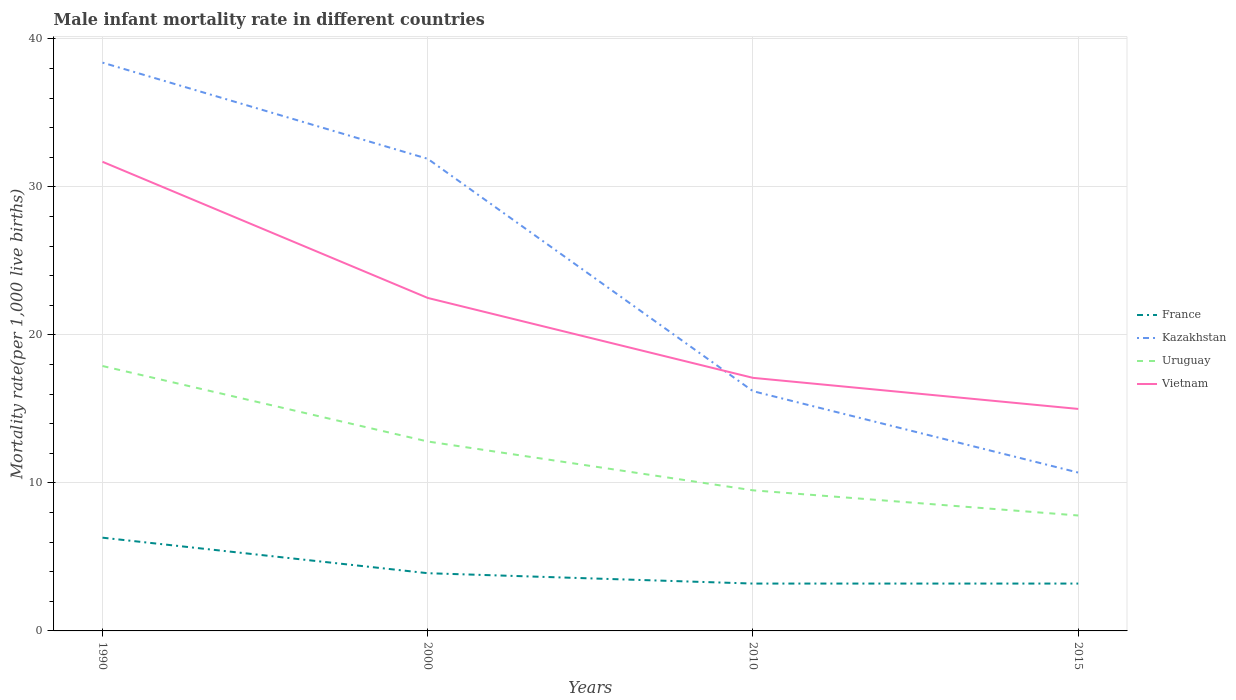How many different coloured lines are there?
Ensure brevity in your answer.  4. Does the line corresponding to Kazakhstan intersect with the line corresponding to France?
Your answer should be compact. No. Across all years, what is the maximum male infant mortality rate in France?
Offer a terse response. 3.2. In which year was the male infant mortality rate in Vietnam maximum?
Provide a short and direct response. 2015. What is the total male infant mortality rate in Kazakhstan in the graph?
Ensure brevity in your answer.  6.5. What is the difference between the highest and the second highest male infant mortality rate in Uruguay?
Give a very brief answer. 10.1. How many years are there in the graph?
Your answer should be compact. 4. Does the graph contain grids?
Your answer should be very brief. Yes. How many legend labels are there?
Your answer should be very brief. 4. What is the title of the graph?
Your answer should be compact. Male infant mortality rate in different countries. Does "Zimbabwe" appear as one of the legend labels in the graph?
Keep it short and to the point. No. What is the label or title of the Y-axis?
Provide a short and direct response. Mortality rate(per 1,0 live births). What is the Mortality rate(per 1,000 live births) of France in 1990?
Offer a very short reply. 6.3. What is the Mortality rate(per 1,000 live births) of Kazakhstan in 1990?
Keep it short and to the point. 38.4. What is the Mortality rate(per 1,000 live births) in Vietnam in 1990?
Offer a terse response. 31.7. What is the Mortality rate(per 1,000 live births) in France in 2000?
Your answer should be very brief. 3.9. What is the Mortality rate(per 1,000 live births) in Kazakhstan in 2000?
Your answer should be very brief. 31.9. What is the Mortality rate(per 1,000 live births) in Uruguay in 2000?
Give a very brief answer. 12.8. What is the Mortality rate(per 1,000 live births) in Vietnam in 2000?
Your answer should be very brief. 22.5. What is the Mortality rate(per 1,000 live births) in Uruguay in 2010?
Provide a succinct answer. 9.5. What is the Mortality rate(per 1,000 live births) in Vietnam in 2010?
Offer a very short reply. 17.1. What is the Mortality rate(per 1,000 live births) of France in 2015?
Make the answer very short. 3.2. What is the Mortality rate(per 1,000 live births) in Kazakhstan in 2015?
Offer a very short reply. 10.7. Across all years, what is the maximum Mortality rate(per 1,000 live births) of France?
Provide a short and direct response. 6.3. Across all years, what is the maximum Mortality rate(per 1,000 live births) of Kazakhstan?
Your answer should be compact. 38.4. Across all years, what is the maximum Mortality rate(per 1,000 live births) of Vietnam?
Your answer should be compact. 31.7. Across all years, what is the minimum Mortality rate(per 1,000 live births) in Vietnam?
Keep it short and to the point. 15. What is the total Mortality rate(per 1,000 live births) in Kazakhstan in the graph?
Offer a terse response. 97.2. What is the total Mortality rate(per 1,000 live births) of Vietnam in the graph?
Keep it short and to the point. 86.3. What is the difference between the Mortality rate(per 1,000 live births) of Uruguay in 1990 and that in 2000?
Keep it short and to the point. 5.1. What is the difference between the Mortality rate(per 1,000 live births) of Vietnam in 1990 and that in 2000?
Provide a short and direct response. 9.2. What is the difference between the Mortality rate(per 1,000 live births) of Kazakhstan in 1990 and that in 2010?
Your response must be concise. 22.2. What is the difference between the Mortality rate(per 1,000 live births) in Uruguay in 1990 and that in 2010?
Ensure brevity in your answer.  8.4. What is the difference between the Mortality rate(per 1,000 live births) in Vietnam in 1990 and that in 2010?
Your answer should be very brief. 14.6. What is the difference between the Mortality rate(per 1,000 live births) of France in 1990 and that in 2015?
Give a very brief answer. 3.1. What is the difference between the Mortality rate(per 1,000 live births) of Kazakhstan in 1990 and that in 2015?
Ensure brevity in your answer.  27.7. What is the difference between the Mortality rate(per 1,000 live births) of Uruguay in 1990 and that in 2015?
Your answer should be very brief. 10.1. What is the difference between the Mortality rate(per 1,000 live births) of France in 2000 and that in 2010?
Offer a terse response. 0.7. What is the difference between the Mortality rate(per 1,000 live births) in Kazakhstan in 2000 and that in 2010?
Give a very brief answer. 15.7. What is the difference between the Mortality rate(per 1,000 live births) in Uruguay in 2000 and that in 2010?
Keep it short and to the point. 3.3. What is the difference between the Mortality rate(per 1,000 live births) in Kazakhstan in 2000 and that in 2015?
Your response must be concise. 21.2. What is the difference between the Mortality rate(per 1,000 live births) in Uruguay in 2000 and that in 2015?
Provide a succinct answer. 5. What is the difference between the Mortality rate(per 1,000 live births) in Vietnam in 2000 and that in 2015?
Provide a succinct answer. 7.5. What is the difference between the Mortality rate(per 1,000 live births) of France in 2010 and that in 2015?
Keep it short and to the point. 0. What is the difference between the Mortality rate(per 1,000 live births) of Kazakhstan in 2010 and that in 2015?
Provide a succinct answer. 5.5. What is the difference between the Mortality rate(per 1,000 live births) of Vietnam in 2010 and that in 2015?
Your answer should be compact. 2.1. What is the difference between the Mortality rate(per 1,000 live births) of France in 1990 and the Mortality rate(per 1,000 live births) of Kazakhstan in 2000?
Your answer should be compact. -25.6. What is the difference between the Mortality rate(per 1,000 live births) of France in 1990 and the Mortality rate(per 1,000 live births) of Vietnam in 2000?
Offer a very short reply. -16.2. What is the difference between the Mortality rate(per 1,000 live births) in Kazakhstan in 1990 and the Mortality rate(per 1,000 live births) in Uruguay in 2000?
Make the answer very short. 25.6. What is the difference between the Mortality rate(per 1,000 live births) of France in 1990 and the Mortality rate(per 1,000 live births) of Kazakhstan in 2010?
Make the answer very short. -9.9. What is the difference between the Mortality rate(per 1,000 live births) in France in 1990 and the Mortality rate(per 1,000 live births) in Uruguay in 2010?
Make the answer very short. -3.2. What is the difference between the Mortality rate(per 1,000 live births) of Kazakhstan in 1990 and the Mortality rate(per 1,000 live births) of Uruguay in 2010?
Your answer should be compact. 28.9. What is the difference between the Mortality rate(per 1,000 live births) in Kazakhstan in 1990 and the Mortality rate(per 1,000 live births) in Vietnam in 2010?
Your answer should be very brief. 21.3. What is the difference between the Mortality rate(per 1,000 live births) in Uruguay in 1990 and the Mortality rate(per 1,000 live births) in Vietnam in 2010?
Give a very brief answer. 0.8. What is the difference between the Mortality rate(per 1,000 live births) of France in 1990 and the Mortality rate(per 1,000 live births) of Uruguay in 2015?
Offer a terse response. -1.5. What is the difference between the Mortality rate(per 1,000 live births) of Kazakhstan in 1990 and the Mortality rate(per 1,000 live births) of Uruguay in 2015?
Your answer should be very brief. 30.6. What is the difference between the Mortality rate(per 1,000 live births) in Kazakhstan in 1990 and the Mortality rate(per 1,000 live births) in Vietnam in 2015?
Offer a very short reply. 23.4. What is the difference between the Mortality rate(per 1,000 live births) in France in 2000 and the Mortality rate(per 1,000 live births) in Kazakhstan in 2010?
Give a very brief answer. -12.3. What is the difference between the Mortality rate(per 1,000 live births) of France in 2000 and the Mortality rate(per 1,000 live births) of Uruguay in 2010?
Your response must be concise. -5.6. What is the difference between the Mortality rate(per 1,000 live births) of Kazakhstan in 2000 and the Mortality rate(per 1,000 live births) of Uruguay in 2010?
Provide a short and direct response. 22.4. What is the difference between the Mortality rate(per 1,000 live births) in Kazakhstan in 2000 and the Mortality rate(per 1,000 live births) in Vietnam in 2010?
Offer a very short reply. 14.8. What is the difference between the Mortality rate(per 1,000 live births) in Uruguay in 2000 and the Mortality rate(per 1,000 live births) in Vietnam in 2010?
Your answer should be very brief. -4.3. What is the difference between the Mortality rate(per 1,000 live births) in France in 2000 and the Mortality rate(per 1,000 live births) in Uruguay in 2015?
Provide a short and direct response. -3.9. What is the difference between the Mortality rate(per 1,000 live births) of Kazakhstan in 2000 and the Mortality rate(per 1,000 live births) of Uruguay in 2015?
Give a very brief answer. 24.1. What is the difference between the Mortality rate(per 1,000 live births) of Kazakhstan in 2000 and the Mortality rate(per 1,000 live births) of Vietnam in 2015?
Offer a very short reply. 16.9. What is the average Mortality rate(per 1,000 live births) in France per year?
Your answer should be compact. 4.15. What is the average Mortality rate(per 1,000 live births) of Kazakhstan per year?
Your answer should be compact. 24.3. What is the average Mortality rate(per 1,000 live births) in Vietnam per year?
Make the answer very short. 21.57. In the year 1990, what is the difference between the Mortality rate(per 1,000 live births) of France and Mortality rate(per 1,000 live births) of Kazakhstan?
Provide a short and direct response. -32.1. In the year 1990, what is the difference between the Mortality rate(per 1,000 live births) of France and Mortality rate(per 1,000 live births) of Uruguay?
Your response must be concise. -11.6. In the year 1990, what is the difference between the Mortality rate(per 1,000 live births) of France and Mortality rate(per 1,000 live births) of Vietnam?
Your answer should be very brief. -25.4. In the year 1990, what is the difference between the Mortality rate(per 1,000 live births) in Kazakhstan and Mortality rate(per 1,000 live births) in Uruguay?
Give a very brief answer. 20.5. In the year 1990, what is the difference between the Mortality rate(per 1,000 live births) in Kazakhstan and Mortality rate(per 1,000 live births) in Vietnam?
Your answer should be very brief. 6.7. In the year 2000, what is the difference between the Mortality rate(per 1,000 live births) in France and Mortality rate(per 1,000 live births) in Kazakhstan?
Provide a short and direct response. -28. In the year 2000, what is the difference between the Mortality rate(per 1,000 live births) of France and Mortality rate(per 1,000 live births) of Vietnam?
Offer a very short reply. -18.6. In the year 2000, what is the difference between the Mortality rate(per 1,000 live births) of Kazakhstan and Mortality rate(per 1,000 live births) of Uruguay?
Provide a succinct answer. 19.1. In the year 2000, what is the difference between the Mortality rate(per 1,000 live births) in Kazakhstan and Mortality rate(per 1,000 live births) in Vietnam?
Provide a succinct answer. 9.4. In the year 2000, what is the difference between the Mortality rate(per 1,000 live births) of Uruguay and Mortality rate(per 1,000 live births) of Vietnam?
Provide a short and direct response. -9.7. In the year 2010, what is the difference between the Mortality rate(per 1,000 live births) of France and Mortality rate(per 1,000 live births) of Kazakhstan?
Your answer should be very brief. -13. In the year 2010, what is the difference between the Mortality rate(per 1,000 live births) of Kazakhstan and Mortality rate(per 1,000 live births) of Uruguay?
Keep it short and to the point. 6.7. In the year 2010, what is the difference between the Mortality rate(per 1,000 live births) in Kazakhstan and Mortality rate(per 1,000 live births) in Vietnam?
Give a very brief answer. -0.9. In the year 2015, what is the difference between the Mortality rate(per 1,000 live births) in France and Mortality rate(per 1,000 live births) in Uruguay?
Offer a very short reply. -4.6. In the year 2015, what is the difference between the Mortality rate(per 1,000 live births) in Kazakhstan and Mortality rate(per 1,000 live births) in Uruguay?
Provide a succinct answer. 2.9. In the year 2015, what is the difference between the Mortality rate(per 1,000 live births) in Kazakhstan and Mortality rate(per 1,000 live births) in Vietnam?
Ensure brevity in your answer.  -4.3. What is the ratio of the Mortality rate(per 1,000 live births) of France in 1990 to that in 2000?
Offer a very short reply. 1.62. What is the ratio of the Mortality rate(per 1,000 live births) of Kazakhstan in 1990 to that in 2000?
Provide a short and direct response. 1.2. What is the ratio of the Mortality rate(per 1,000 live births) in Uruguay in 1990 to that in 2000?
Your response must be concise. 1.4. What is the ratio of the Mortality rate(per 1,000 live births) of Vietnam in 1990 to that in 2000?
Give a very brief answer. 1.41. What is the ratio of the Mortality rate(per 1,000 live births) of France in 1990 to that in 2010?
Keep it short and to the point. 1.97. What is the ratio of the Mortality rate(per 1,000 live births) of Kazakhstan in 1990 to that in 2010?
Offer a very short reply. 2.37. What is the ratio of the Mortality rate(per 1,000 live births) of Uruguay in 1990 to that in 2010?
Provide a short and direct response. 1.88. What is the ratio of the Mortality rate(per 1,000 live births) in Vietnam in 1990 to that in 2010?
Your answer should be compact. 1.85. What is the ratio of the Mortality rate(per 1,000 live births) in France in 1990 to that in 2015?
Offer a terse response. 1.97. What is the ratio of the Mortality rate(per 1,000 live births) in Kazakhstan in 1990 to that in 2015?
Keep it short and to the point. 3.59. What is the ratio of the Mortality rate(per 1,000 live births) in Uruguay in 1990 to that in 2015?
Your answer should be compact. 2.29. What is the ratio of the Mortality rate(per 1,000 live births) of Vietnam in 1990 to that in 2015?
Your answer should be very brief. 2.11. What is the ratio of the Mortality rate(per 1,000 live births) of France in 2000 to that in 2010?
Your answer should be compact. 1.22. What is the ratio of the Mortality rate(per 1,000 live births) in Kazakhstan in 2000 to that in 2010?
Keep it short and to the point. 1.97. What is the ratio of the Mortality rate(per 1,000 live births) in Uruguay in 2000 to that in 2010?
Provide a succinct answer. 1.35. What is the ratio of the Mortality rate(per 1,000 live births) in Vietnam in 2000 to that in 2010?
Your answer should be very brief. 1.32. What is the ratio of the Mortality rate(per 1,000 live births) of France in 2000 to that in 2015?
Offer a very short reply. 1.22. What is the ratio of the Mortality rate(per 1,000 live births) of Kazakhstan in 2000 to that in 2015?
Keep it short and to the point. 2.98. What is the ratio of the Mortality rate(per 1,000 live births) in Uruguay in 2000 to that in 2015?
Give a very brief answer. 1.64. What is the ratio of the Mortality rate(per 1,000 live births) of Kazakhstan in 2010 to that in 2015?
Ensure brevity in your answer.  1.51. What is the ratio of the Mortality rate(per 1,000 live births) of Uruguay in 2010 to that in 2015?
Your answer should be very brief. 1.22. What is the ratio of the Mortality rate(per 1,000 live births) in Vietnam in 2010 to that in 2015?
Offer a very short reply. 1.14. What is the difference between the highest and the second highest Mortality rate(per 1,000 live births) of France?
Provide a succinct answer. 2.4. What is the difference between the highest and the second highest Mortality rate(per 1,000 live births) in Kazakhstan?
Make the answer very short. 6.5. What is the difference between the highest and the lowest Mortality rate(per 1,000 live births) of Kazakhstan?
Provide a succinct answer. 27.7. What is the difference between the highest and the lowest Mortality rate(per 1,000 live births) in Uruguay?
Make the answer very short. 10.1. 